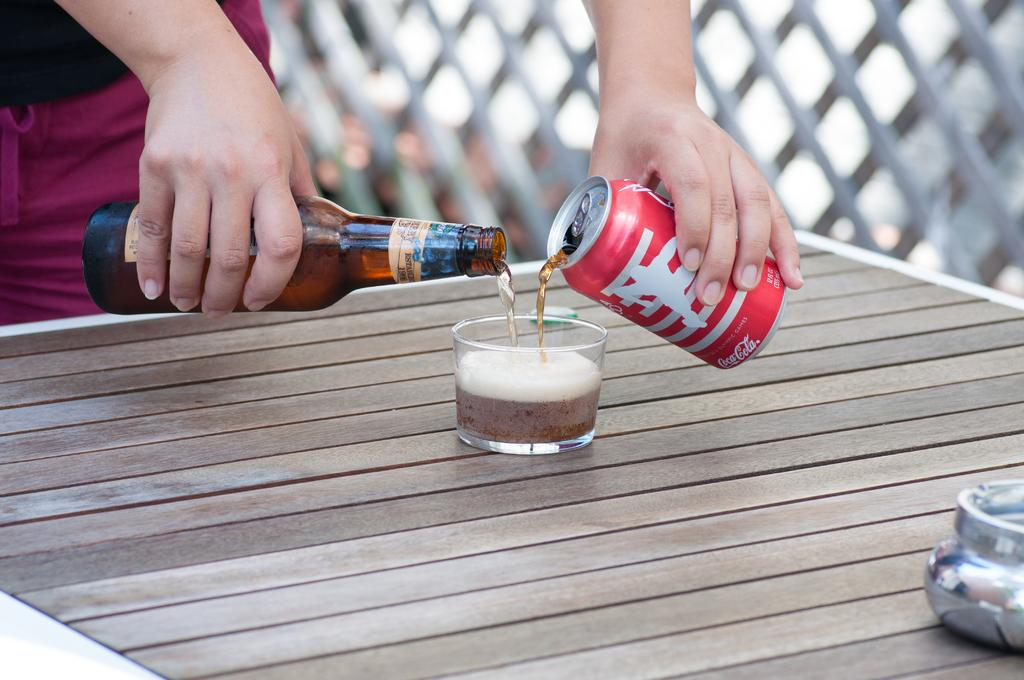Who is present in the image? There is a man in the image. What is the man holding in the image? The man is holding a bottle and a can. What is the man doing with the liquid in the image? The man is pouring liquid into a glass. What is on the table in the image? There is a vessel on the table. What type of credit card is the man using to open the bottle in the image? There is no credit card present in the image, and the man is not using any tool to open the bottle. 